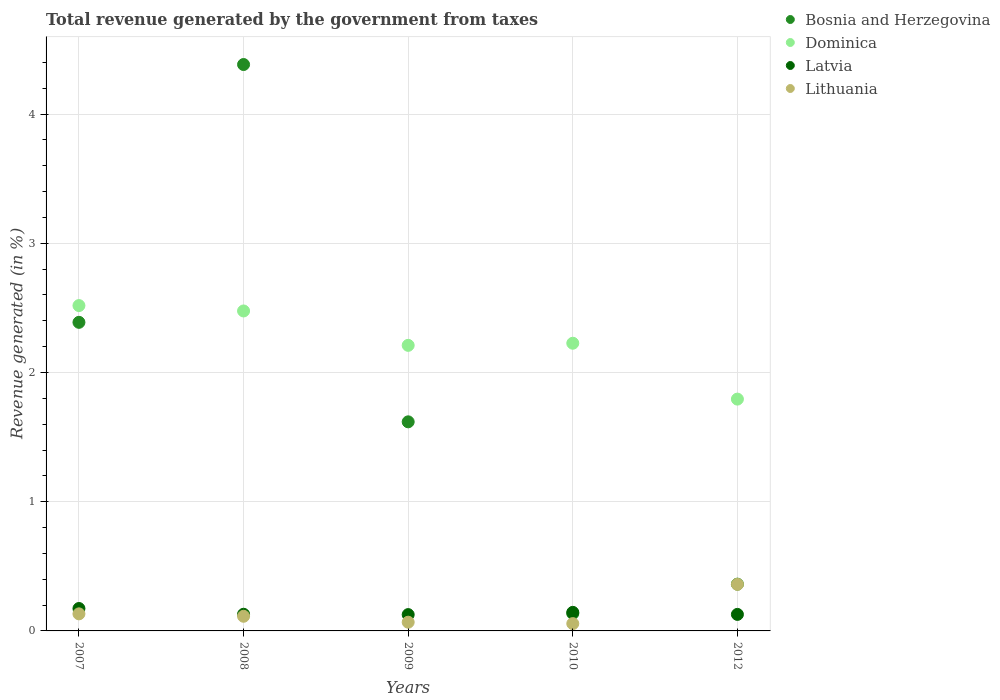How many different coloured dotlines are there?
Provide a short and direct response. 4. Is the number of dotlines equal to the number of legend labels?
Offer a terse response. Yes. What is the total revenue generated in Latvia in 2009?
Offer a very short reply. 0.13. Across all years, what is the maximum total revenue generated in Dominica?
Make the answer very short. 2.52. Across all years, what is the minimum total revenue generated in Dominica?
Provide a succinct answer. 1.79. What is the total total revenue generated in Latvia in the graph?
Make the answer very short. 0.7. What is the difference between the total revenue generated in Dominica in 2010 and that in 2012?
Offer a very short reply. 0.43. What is the difference between the total revenue generated in Lithuania in 2007 and the total revenue generated in Dominica in 2010?
Provide a succinct answer. -2.09. What is the average total revenue generated in Latvia per year?
Provide a short and direct response. 0.14. In the year 2010, what is the difference between the total revenue generated in Dominica and total revenue generated in Lithuania?
Ensure brevity in your answer.  2.17. What is the ratio of the total revenue generated in Latvia in 2009 to that in 2010?
Offer a terse response. 0.88. Is the total revenue generated in Bosnia and Herzegovina in 2009 less than that in 2012?
Your answer should be compact. No. Is the difference between the total revenue generated in Dominica in 2007 and 2012 greater than the difference between the total revenue generated in Lithuania in 2007 and 2012?
Give a very brief answer. Yes. What is the difference between the highest and the second highest total revenue generated in Latvia?
Ensure brevity in your answer.  0.03. What is the difference between the highest and the lowest total revenue generated in Dominica?
Your response must be concise. 0.72. Is the sum of the total revenue generated in Dominica in 2010 and 2012 greater than the maximum total revenue generated in Latvia across all years?
Ensure brevity in your answer.  Yes. Is it the case that in every year, the sum of the total revenue generated in Latvia and total revenue generated in Bosnia and Herzegovina  is greater than the sum of total revenue generated in Lithuania and total revenue generated in Dominica?
Offer a terse response. No. Is it the case that in every year, the sum of the total revenue generated in Latvia and total revenue generated in Dominica  is greater than the total revenue generated in Bosnia and Herzegovina?
Make the answer very short. No. Does the total revenue generated in Latvia monotonically increase over the years?
Your answer should be compact. No. How many dotlines are there?
Keep it short and to the point. 4. What is the difference between two consecutive major ticks on the Y-axis?
Keep it short and to the point. 1. Does the graph contain any zero values?
Offer a very short reply. No. Does the graph contain grids?
Ensure brevity in your answer.  Yes. Where does the legend appear in the graph?
Offer a very short reply. Top right. How are the legend labels stacked?
Provide a short and direct response. Vertical. What is the title of the graph?
Your response must be concise. Total revenue generated by the government from taxes. What is the label or title of the Y-axis?
Your response must be concise. Revenue generated (in %). What is the Revenue generated (in %) in Bosnia and Herzegovina in 2007?
Your answer should be compact. 2.39. What is the Revenue generated (in %) of Dominica in 2007?
Provide a short and direct response. 2.52. What is the Revenue generated (in %) in Latvia in 2007?
Provide a succinct answer. 0.17. What is the Revenue generated (in %) of Lithuania in 2007?
Offer a terse response. 0.13. What is the Revenue generated (in %) in Bosnia and Herzegovina in 2008?
Make the answer very short. 4.38. What is the Revenue generated (in %) in Dominica in 2008?
Offer a terse response. 2.48. What is the Revenue generated (in %) of Latvia in 2008?
Your answer should be compact. 0.13. What is the Revenue generated (in %) of Lithuania in 2008?
Give a very brief answer. 0.11. What is the Revenue generated (in %) in Bosnia and Herzegovina in 2009?
Offer a very short reply. 1.62. What is the Revenue generated (in %) in Dominica in 2009?
Your answer should be very brief. 2.21. What is the Revenue generated (in %) of Latvia in 2009?
Your answer should be compact. 0.13. What is the Revenue generated (in %) in Lithuania in 2009?
Your response must be concise. 0.07. What is the Revenue generated (in %) in Bosnia and Herzegovina in 2010?
Your answer should be very brief. 0.13. What is the Revenue generated (in %) in Dominica in 2010?
Make the answer very short. 2.23. What is the Revenue generated (in %) in Latvia in 2010?
Offer a terse response. 0.14. What is the Revenue generated (in %) of Lithuania in 2010?
Provide a succinct answer. 0.06. What is the Revenue generated (in %) of Bosnia and Herzegovina in 2012?
Keep it short and to the point. 0.36. What is the Revenue generated (in %) in Dominica in 2012?
Your answer should be compact. 1.79. What is the Revenue generated (in %) of Latvia in 2012?
Offer a terse response. 0.13. What is the Revenue generated (in %) of Lithuania in 2012?
Make the answer very short. 0.36. Across all years, what is the maximum Revenue generated (in %) of Bosnia and Herzegovina?
Keep it short and to the point. 4.38. Across all years, what is the maximum Revenue generated (in %) of Dominica?
Provide a short and direct response. 2.52. Across all years, what is the maximum Revenue generated (in %) in Latvia?
Provide a short and direct response. 0.17. Across all years, what is the maximum Revenue generated (in %) of Lithuania?
Keep it short and to the point. 0.36. Across all years, what is the minimum Revenue generated (in %) of Bosnia and Herzegovina?
Your response must be concise. 0.13. Across all years, what is the minimum Revenue generated (in %) of Dominica?
Offer a very short reply. 1.79. Across all years, what is the minimum Revenue generated (in %) of Latvia?
Ensure brevity in your answer.  0.13. Across all years, what is the minimum Revenue generated (in %) of Lithuania?
Offer a very short reply. 0.06. What is the total Revenue generated (in %) of Bosnia and Herzegovina in the graph?
Offer a very short reply. 8.89. What is the total Revenue generated (in %) of Dominica in the graph?
Offer a terse response. 11.22. What is the total Revenue generated (in %) in Latvia in the graph?
Provide a succinct answer. 0.7. What is the total Revenue generated (in %) in Lithuania in the graph?
Give a very brief answer. 0.73. What is the difference between the Revenue generated (in %) of Bosnia and Herzegovina in 2007 and that in 2008?
Keep it short and to the point. -2. What is the difference between the Revenue generated (in %) of Dominica in 2007 and that in 2008?
Make the answer very short. 0.04. What is the difference between the Revenue generated (in %) in Latvia in 2007 and that in 2008?
Keep it short and to the point. 0.04. What is the difference between the Revenue generated (in %) of Lithuania in 2007 and that in 2008?
Your answer should be very brief. 0.02. What is the difference between the Revenue generated (in %) in Bosnia and Herzegovina in 2007 and that in 2009?
Provide a succinct answer. 0.77. What is the difference between the Revenue generated (in %) of Dominica in 2007 and that in 2009?
Your answer should be very brief. 0.31. What is the difference between the Revenue generated (in %) of Latvia in 2007 and that in 2009?
Provide a short and direct response. 0.05. What is the difference between the Revenue generated (in %) of Lithuania in 2007 and that in 2009?
Keep it short and to the point. 0.06. What is the difference between the Revenue generated (in %) in Bosnia and Herzegovina in 2007 and that in 2010?
Give a very brief answer. 2.25. What is the difference between the Revenue generated (in %) of Dominica in 2007 and that in 2010?
Provide a succinct answer. 0.29. What is the difference between the Revenue generated (in %) of Latvia in 2007 and that in 2010?
Give a very brief answer. 0.03. What is the difference between the Revenue generated (in %) in Lithuania in 2007 and that in 2010?
Provide a short and direct response. 0.08. What is the difference between the Revenue generated (in %) in Bosnia and Herzegovina in 2007 and that in 2012?
Your answer should be very brief. 2.03. What is the difference between the Revenue generated (in %) of Dominica in 2007 and that in 2012?
Your answer should be very brief. 0.72. What is the difference between the Revenue generated (in %) in Latvia in 2007 and that in 2012?
Provide a succinct answer. 0.05. What is the difference between the Revenue generated (in %) of Lithuania in 2007 and that in 2012?
Provide a succinct answer. -0.23. What is the difference between the Revenue generated (in %) in Bosnia and Herzegovina in 2008 and that in 2009?
Ensure brevity in your answer.  2.76. What is the difference between the Revenue generated (in %) in Dominica in 2008 and that in 2009?
Your answer should be compact. 0.27. What is the difference between the Revenue generated (in %) of Latvia in 2008 and that in 2009?
Provide a succinct answer. 0. What is the difference between the Revenue generated (in %) in Lithuania in 2008 and that in 2009?
Keep it short and to the point. 0.05. What is the difference between the Revenue generated (in %) of Bosnia and Herzegovina in 2008 and that in 2010?
Your answer should be compact. 4.25. What is the difference between the Revenue generated (in %) in Dominica in 2008 and that in 2010?
Offer a very short reply. 0.25. What is the difference between the Revenue generated (in %) of Latvia in 2008 and that in 2010?
Keep it short and to the point. -0.01. What is the difference between the Revenue generated (in %) of Lithuania in 2008 and that in 2010?
Your answer should be very brief. 0.06. What is the difference between the Revenue generated (in %) of Bosnia and Herzegovina in 2008 and that in 2012?
Provide a short and direct response. 4.02. What is the difference between the Revenue generated (in %) of Dominica in 2008 and that in 2012?
Your answer should be compact. 0.68. What is the difference between the Revenue generated (in %) in Latvia in 2008 and that in 2012?
Offer a terse response. 0. What is the difference between the Revenue generated (in %) in Lithuania in 2008 and that in 2012?
Offer a terse response. -0.25. What is the difference between the Revenue generated (in %) in Bosnia and Herzegovina in 2009 and that in 2010?
Your response must be concise. 1.48. What is the difference between the Revenue generated (in %) of Dominica in 2009 and that in 2010?
Provide a succinct answer. -0.02. What is the difference between the Revenue generated (in %) in Latvia in 2009 and that in 2010?
Your answer should be very brief. -0.02. What is the difference between the Revenue generated (in %) of Lithuania in 2009 and that in 2010?
Your answer should be very brief. 0.01. What is the difference between the Revenue generated (in %) of Bosnia and Herzegovina in 2009 and that in 2012?
Offer a terse response. 1.26. What is the difference between the Revenue generated (in %) of Dominica in 2009 and that in 2012?
Ensure brevity in your answer.  0.42. What is the difference between the Revenue generated (in %) in Latvia in 2009 and that in 2012?
Keep it short and to the point. -0. What is the difference between the Revenue generated (in %) in Lithuania in 2009 and that in 2012?
Your answer should be compact. -0.29. What is the difference between the Revenue generated (in %) in Bosnia and Herzegovina in 2010 and that in 2012?
Your response must be concise. -0.23. What is the difference between the Revenue generated (in %) in Dominica in 2010 and that in 2012?
Your response must be concise. 0.43. What is the difference between the Revenue generated (in %) of Latvia in 2010 and that in 2012?
Give a very brief answer. 0.02. What is the difference between the Revenue generated (in %) of Lithuania in 2010 and that in 2012?
Ensure brevity in your answer.  -0.3. What is the difference between the Revenue generated (in %) of Bosnia and Herzegovina in 2007 and the Revenue generated (in %) of Dominica in 2008?
Your answer should be very brief. -0.09. What is the difference between the Revenue generated (in %) of Bosnia and Herzegovina in 2007 and the Revenue generated (in %) of Latvia in 2008?
Offer a very short reply. 2.26. What is the difference between the Revenue generated (in %) of Bosnia and Herzegovina in 2007 and the Revenue generated (in %) of Lithuania in 2008?
Provide a succinct answer. 2.27. What is the difference between the Revenue generated (in %) in Dominica in 2007 and the Revenue generated (in %) in Latvia in 2008?
Ensure brevity in your answer.  2.39. What is the difference between the Revenue generated (in %) in Dominica in 2007 and the Revenue generated (in %) in Lithuania in 2008?
Your answer should be compact. 2.4. What is the difference between the Revenue generated (in %) of Latvia in 2007 and the Revenue generated (in %) of Lithuania in 2008?
Your answer should be compact. 0.06. What is the difference between the Revenue generated (in %) of Bosnia and Herzegovina in 2007 and the Revenue generated (in %) of Dominica in 2009?
Provide a short and direct response. 0.18. What is the difference between the Revenue generated (in %) of Bosnia and Herzegovina in 2007 and the Revenue generated (in %) of Latvia in 2009?
Your answer should be very brief. 2.26. What is the difference between the Revenue generated (in %) of Bosnia and Herzegovina in 2007 and the Revenue generated (in %) of Lithuania in 2009?
Offer a very short reply. 2.32. What is the difference between the Revenue generated (in %) of Dominica in 2007 and the Revenue generated (in %) of Latvia in 2009?
Offer a terse response. 2.39. What is the difference between the Revenue generated (in %) in Dominica in 2007 and the Revenue generated (in %) in Lithuania in 2009?
Provide a succinct answer. 2.45. What is the difference between the Revenue generated (in %) in Latvia in 2007 and the Revenue generated (in %) in Lithuania in 2009?
Your response must be concise. 0.11. What is the difference between the Revenue generated (in %) of Bosnia and Herzegovina in 2007 and the Revenue generated (in %) of Dominica in 2010?
Offer a terse response. 0.16. What is the difference between the Revenue generated (in %) of Bosnia and Herzegovina in 2007 and the Revenue generated (in %) of Latvia in 2010?
Keep it short and to the point. 2.24. What is the difference between the Revenue generated (in %) of Bosnia and Herzegovina in 2007 and the Revenue generated (in %) of Lithuania in 2010?
Offer a terse response. 2.33. What is the difference between the Revenue generated (in %) of Dominica in 2007 and the Revenue generated (in %) of Latvia in 2010?
Provide a succinct answer. 2.37. What is the difference between the Revenue generated (in %) in Dominica in 2007 and the Revenue generated (in %) in Lithuania in 2010?
Your answer should be compact. 2.46. What is the difference between the Revenue generated (in %) of Latvia in 2007 and the Revenue generated (in %) of Lithuania in 2010?
Give a very brief answer. 0.12. What is the difference between the Revenue generated (in %) in Bosnia and Herzegovina in 2007 and the Revenue generated (in %) in Dominica in 2012?
Give a very brief answer. 0.59. What is the difference between the Revenue generated (in %) of Bosnia and Herzegovina in 2007 and the Revenue generated (in %) of Latvia in 2012?
Your response must be concise. 2.26. What is the difference between the Revenue generated (in %) of Bosnia and Herzegovina in 2007 and the Revenue generated (in %) of Lithuania in 2012?
Offer a terse response. 2.03. What is the difference between the Revenue generated (in %) of Dominica in 2007 and the Revenue generated (in %) of Latvia in 2012?
Your answer should be compact. 2.39. What is the difference between the Revenue generated (in %) in Dominica in 2007 and the Revenue generated (in %) in Lithuania in 2012?
Provide a succinct answer. 2.16. What is the difference between the Revenue generated (in %) of Latvia in 2007 and the Revenue generated (in %) of Lithuania in 2012?
Your answer should be compact. -0.19. What is the difference between the Revenue generated (in %) in Bosnia and Herzegovina in 2008 and the Revenue generated (in %) in Dominica in 2009?
Provide a short and direct response. 2.17. What is the difference between the Revenue generated (in %) in Bosnia and Herzegovina in 2008 and the Revenue generated (in %) in Latvia in 2009?
Provide a succinct answer. 4.26. What is the difference between the Revenue generated (in %) in Bosnia and Herzegovina in 2008 and the Revenue generated (in %) in Lithuania in 2009?
Your answer should be compact. 4.32. What is the difference between the Revenue generated (in %) in Dominica in 2008 and the Revenue generated (in %) in Latvia in 2009?
Your answer should be very brief. 2.35. What is the difference between the Revenue generated (in %) of Dominica in 2008 and the Revenue generated (in %) of Lithuania in 2009?
Your answer should be compact. 2.41. What is the difference between the Revenue generated (in %) of Latvia in 2008 and the Revenue generated (in %) of Lithuania in 2009?
Provide a short and direct response. 0.06. What is the difference between the Revenue generated (in %) in Bosnia and Herzegovina in 2008 and the Revenue generated (in %) in Dominica in 2010?
Offer a very short reply. 2.16. What is the difference between the Revenue generated (in %) in Bosnia and Herzegovina in 2008 and the Revenue generated (in %) in Latvia in 2010?
Make the answer very short. 4.24. What is the difference between the Revenue generated (in %) of Bosnia and Herzegovina in 2008 and the Revenue generated (in %) of Lithuania in 2010?
Keep it short and to the point. 4.33. What is the difference between the Revenue generated (in %) in Dominica in 2008 and the Revenue generated (in %) in Latvia in 2010?
Offer a very short reply. 2.33. What is the difference between the Revenue generated (in %) of Dominica in 2008 and the Revenue generated (in %) of Lithuania in 2010?
Offer a terse response. 2.42. What is the difference between the Revenue generated (in %) in Latvia in 2008 and the Revenue generated (in %) in Lithuania in 2010?
Give a very brief answer. 0.07. What is the difference between the Revenue generated (in %) of Bosnia and Herzegovina in 2008 and the Revenue generated (in %) of Dominica in 2012?
Give a very brief answer. 2.59. What is the difference between the Revenue generated (in %) in Bosnia and Herzegovina in 2008 and the Revenue generated (in %) in Latvia in 2012?
Make the answer very short. 4.26. What is the difference between the Revenue generated (in %) of Bosnia and Herzegovina in 2008 and the Revenue generated (in %) of Lithuania in 2012?
Ensure brevity in your answer.  4.02. What is the difference between the Revenue generated (in %) of Dominica in 2008 and the Revenue generated (in %) of Latvia in 2012?
Make the answer very short. 2.35. What is the difference between the Revenue generated (in %) of Dominica in 2008 and the Revenue generated (in %) of Lithuania in 2012?
Give a very brief answer. 2.12. What is the difference between the Revenue generated (in %) of Latvia in 2008 and the Revenue generated (in %) of Lithuania in 2012?
Make the answer very short. -0.23. What is the difference between the Revenue generated (in %) of Bosnia and Herzegovina in 2009 and the Revenue generated (in %) of Dominica in 2010?
Your response must be concise. -0.61. What is the difference between the Revenue generated (in %) of Bosnia and Herzegovina in 2009 and the Revenue generated (in %) of Latvia in 2010?
Provide a short and direct response. 1.47. What is the difference between the Revenue generated (in %) in Bosnia and Herzegovina in 2009 and the Revenue generated (in %) in Lithuania in 2010?
Provide a succinct answer. 1.56. What is the difference between the Revenue generated (in %) in Dominica in 2009 and the Revenue generated (in %) in Latvia in 2010?
Your answer should be very brief. 2.07. What is the difference between the Revenue generated (in %) in Dominica in 2009 and the Revenue generated (in %) in Lithuania in 2010?
Offer a very short reply. 2.15. What is the difference between the Revenue generated (in %) of Latvia in 2009 and the Revenue generated (in %) of Lithuania in 2010?
Give a very brief answer. 0.07. What is the difference between the Revenue generated (in %) of Bosnia and Herzegovina in 2009 and the Revenue generated (in %) of Dominica in 2012?
Your response must be concise. -0.18. What is the difference between the Revenue generated (in %) of Bosnia and Herzegovina in 2009 and the Revenue generated (in %) of Latvia in 2012?
Your response must be concise. 1.49. What is the difference between the Revenue generated (in %) in Bosnia and Herzegovina in 2009 and the Revenue generated (in %) in Lithuania in 2012?
Ensure brevity in your answer.  1.26. What is the difference between the Revenue generated (in %) in Dominica in 2009 and the Revenue generated (in %) in Latvia in 2012?
Your answer should be compact. 2.08. What is the difference between the Revenue generated (in %) of Dominica in 2009 and the Revenue generated (in %) of Lithuania in 2012?
Your answer should be very brief. 1.85. What is the difference between the Revenue generated (in %) of Latvia in 2009 and the Revenue generated (in %) of Lithuania in 2012?
Offer a very short reply. -0.23. What is the difference between the Revenue generated (in %) of Bosnia and Herzegovina in 2010 and the Revenue generated (in %) of Dominica in 2012?
Give a very brief answer. -1.66. What is the difference between the Revenue generated (in %) in Bosnia and Herzegovina in 2010 and the Revenue generated (in %) in Latvia in 2012?
Your answer should be compact. 0.01. What is the difference between the Revenue generated (in %) of Bosnia and Herzegovina in 2010 and the Revenue generated (in %) of Lithuania in 2012?
Provide a short and direct response. -0.23. What is the difference between the Revenue generated (in %) in Dominica in 2010 and the Revenue generated (in %) in Latvia in 2012?
Keep it short and to the point. 2.1. What is the difference between the Revenue generated (in %) of Dominica in 2010 and the Revenue generated (in %) of Lithuania in 2012?
Your response must be concise. 1.87. What is the difference between the Revenue generated (in %) in Latvia in 2010 and the Revenue generated (in %) in Lithuania in 2012?
Give a very brief answer. -0.22. What is the average Revenue generated (in %) in Bosnia and Herzegovina per year?
Your answer should be compact. 1.78. What is the average Revenue generated (in %) of Dominica per year?
Your answer should be very brief. 2.24. What is the average Revenue generated (in %) in Latvia per year?
Ensure brevity in your answer.  0.14. What is the average Revenue generated (in %) in Lithuania per year?
Your answer should be compact. 0.15. In the year 2007, what is the difference between the Revenue generated (in %) in Bosnia and Herzegovina and Revenue generated (in %) in Dominica?
Offer a terse response. -0.13. In the year 2007, what is the difference between the Revenue generated (in %) of Bosnia and Herzegovina and Revenue generated (in %) of Latvia?
Provide a short and direct response. 2.21. In the year 2007, what is the difference between the Revenue generated (in %) in Bosnia and Herzegovina and Revenue generated (in %) in Lithuania?
Offer a terse response. 2.26. In the year 2007, what is the difference between the Revenue generated (in %) of Dominica and Revenue generated (in %) of Latvia?
Make the answer very short. 2.34. In the year 2007, what is the difference between the Revenue generated (in %) of Dominica and Revenue generated (in %) of Lithuania?
Your response must be concise. 2.39. In the year 2007, what is the difference between the Revenue generated (in %) in Latvia and Revenue generated (in %) in Lithuania?
Keep it short and to the point. 0.04. In the year 2008, what is the difference between the Revenue generated (in %) in Bosnia and Herzegovina and Revenue generated (in %) in Dominica?
Ensure brevity in your answer.  1.91. In the year 2008, what is the difference between the Revenue generated (in %) in Bosnia and Herzegovina and Revenue generated (in %) in Latvia?
Provide a succinct answer. 4.25. In the year 2008, what is the difference between the Revenue generated (in %) of Bosnia and Herzegovina and Revenue generated (in %) of Lithuania?
Offer a very short reply. 4.27. In the year 2008, what is the difference between the Revenue generated (in %) in Dominica and Revenue generated (in %) in Latvia?
Ensure brevity in your answer.  2.35. In the year 2008, what is the difference between the Revenue generated (in %) of Dominica and Revenue generated (in %) of Lithuania?
Keep it short and to the point. 2.36. In the year 2008, what is the difference between the Revenue generated (in %) of Latvia and Revenue generated (in %) of Lithuania?
Your answer should be compact. 0.02. In the year 2009, what is the difference between the Revenue generated (in %) of Bosnia and Herzegovina and Revenue generated (in %) of Dominica?
Your answer should be very brief. -0.59. In the year 2009, what is the difference between the Revenue generated (in %) of Bosnia and Herzegovina and Revenue generated (in %) of Latvia?
Your answer should be very brief. 1.49. In the year 2009, what is the difference between the Revenue generated (in %) of Bosnia and Herzegovina and Revenue generated (in %) of Lithuania?
Your answer should be very brief. 1.55. In the year 2009, what is the difference between the Revenue generated (in %) in Dominica and Revenue generated (in %) in Latvia?
Keep it short and to the point. 2.08. In the year 2009, what is the difference between the Revenue generated (in %) of Dominica and Revenue generated (in %) of Lithuania?
Ensure brevity in your answer.  2.14. In the year 2009, what is the difference between the Revenue generated (in %) in Latvia and Revenue generated (in %) in Lithuania?
Provide a succinct answer. 0.06. In the year 2010, what is the difference between the Revenue generated (in %) in Bosnia and Herzegovina and Revenue generated (in %) in Dominica?
Ensure brevity in your answer.  -2.09. In the year 2010, what is the difference between the Revenue generated (in %) in Bosnia and Herzegovina and Revenue generated (in %) in Latvia?
Your answer should be compact. -0.01. In the year 2010, what is the difference between the Revenue generated (in %) of Bosnia and Herzegovina and Revenue generated (in %) of Lithuania?
Your answer should be compact. 0.08. In the year 2010, what is the difference between the Revenue generated (in %) of Dominica and Revenue generated (in %) of Latvia?
Give a very brief answer. 2.08. In the year 2010, what is the difference between the Revenue generated (in %) in Dominica and Revenue generated (in %) in Lithuania?
Give a very brief answer. 2.17. In the year 2010, what is the difference between the Revenue generated (in %) of Latvia and Revenue generated (in %) of Lithuania?
Keep it short and to the point. 0.09. In the year 2012, what is the difference between the Revenue generated (in %) of Bosnia and Herzegovina and Revenue generated (in %) of Dominica?
Provide a short and direct response. -1.43. In the year 2012, what is the difference between the Revenue generated (in %) of Bosnia and Herzegovina and Revenue generated (in %) of Latvia?
Your answer should be very brief. 0.23. In the year 2012, what is the difference between the Revenue generated (in %) of Bosnia and Herzegovina and Revenue generated (in %) of Lithuania?
Offer a terse response. 0. In the year 2012, what is the difference between the Revenue generated (in %) in Dominica and Revenue generated (in %) in Latvia?
Your answer should be very brief. 1.67. In the year 2012, what is the difference between the Revenue generated (in %) of Dominica and Revenue generated (in %) of Lithuania?
Your answer should be very brief. 1.43. In the year 2012, what is the difference between the Revenue generated (in %) of Latvia and Revenue generated (in %) of Lithuania?
Give a very brief answer. -0.23. What is the ratio of the Revenue generated (in %) of Bosnia and Herzegovina in 2007 to that in 2008?
Your answer should be very brief. 0.54. What is the ratio of the Revenue generated (in %) of Dominica in 2007 to that in 2008?
Provide a succinct answer. 1.02. What is the ratio of the Revenue generated (in %) of Latvia in 2007 to that in 2008?
Offer a very short reply. 1.35. What is the ratio of the Revenue generated (in %) in Lithuania in 2007 to that in 2008?
Keep it short and to the point. 1.16. What is the ratio of the Revenue generated (in %) of Bosnia and Herzegovina in 2007 to that in 2009?
Offer a very short reply. 1.48. What is the ratio of the Revenue generated (in %) in Dominica in 2007 to that in 2009?
Your answer should be very brief. 1.14. What is the ratio of the Revenue generated (in %) of Latvia in 2007 to that in 2009?
Ensure brevity in your answer.  1.37. What is the ratio of the Revenue generated (in %) of Lithuania in 2007 to that in 2009?
Ensure brevity in your answer.  1.96. What is the ratio of the Revenue generated (in %) of Bosnia and Herzegovina in 2007 to that in 2010?
Offer a terse response. 17.73. What is the ratio of the Revenue generated (in %) in Dominica in 2007 to that in 2010?
Keep it short and to the point. 1.13. What is the ratio of the Revenue generated (in %) in Latvia in 2007 to that in 2010?
Provide a short and direct response. 1.21. What is the ratio of the Revenue generated (in %) of Lithuania in 2007 to that in 2010?
Ensure brevity in your answer.  2.33. What is the ratio of the Revenue generated (in %) in Bosnia and Herzegovina in 2007 to that in 2012?
Give a very brief answer. 6.6. What is the ratio of the Revenue generated (in %) in Dominica in 2007 to that in 2012?
Your answer should be compact. 1.4. What is the ratio of the Revenue generated (in %) in Latvia in 2007 to that in 2012?
Provide a short and direct response. 1.36. What is the ratio of the Revenue generated (in %) of Lithuania in 2007 to that in 2012?
Make the answer very short. 0.37. What is the ratio of the Revenue generated (in %) in Bosnia and Herzegovina in 2008 to that in 2009?
Offer a very short reply. 2.71. What is the ratio of the Revenue generated (in %) of Dominica in 2008 to that in 2009?
Ensure brevity in your answer.  1.12. What is the ratio of the Revenue generated (in %) of Latvia in 2008 to that in 2009?
Offer a terse response. 1.02. What is the ratio of the Revenue generated (in %) of Lithuania in 2008 to that in 2009?
Provide a short and direct response. 1.68. What is the ratio of the Revenue generated (in %) of Bosnia and Herzegovina in 2008 to that in 2010?
Give a very brief answer. 32.55. What is the ratio of the Revenue generated (in %) of Dominica in 2008 to that in 2010?
Keep it short and to the point. 1.11. What is the ratio of the Revenue generated (in %) in Latvia in 2008 to that in 2010?
Provide a succinct answer. 0.9. What is the ratio of the Revenue generated (in %) of Lithuania in 2008 to that in 2010?
Keep it short and to the point. 2. What is the ratio of the Revenue generated (in %) in Bosnia and Herzegovina in 2008 to that in 2012?
Offer a terse response. 12.11. What is the ratio of the Revenue generated (in %) of Dominica in 2008 to that in 2012?
Give a very brief answer. 1.38. What is the ratio of the Revenue generated (in %) in Latvia in 2008 to that in 2012?
Your response must be concise. 1.01. What is the ratio of the Revenue generated (in %) of Lithuania in 2008 to that in 2012?
Ensure brevity in your answer.  0.31. What is the ratio of the Revenue generated (in %) of Bosnia and Herzegovina in 2009 to that in 2010?
Give a very brief answer. 12.02. What is the ratio of the Revenue generated (in %) of Dominica in 2009 to that in 2010?
Give a very brief answer. 0.99. What is the ratio of the Revenue generated (in %) in Latvia in 2009 to that in 2010?
Provide a succinct answer. 0.88. What is the ratio of the Revenue generated (in %) of Lithuania in 2009 to that in 2010?
Offer a terse response. 1.19. What is the ratio of the Revenue generated (in %) in Bosnia and Herzegovina in 2009 to that in 2012?
Make the answer very short. 4.47. What is the ratio of the Revenue generated (in %) of Dominica in 2009 to that in 2012?
Provide a short and direct response. 1.23. What is the ratio of the Revenue generated (in %) in Latvia in 2009 to that in 2012?
Your response must be concise. 0.99. What is the ratio of the Revenue generated (in %) in Lithuania in 2009 to that in 2012?
Your answer should be very brief. 0.19. What is the ratio of the Revenue generated (in %) of Bosnia and Herzegovina in 2010 to that in 2012?
Provide a succinct answer. 0.37. What is the ratio of the Revenue generated (in %) of Dominica in 2010 to that in 2012?
Your response must be concise. 1.24. What is the ratio of the Revenue generated (in %) of Latvia in 2010 to that in 2012?
Keep it short and to the point. 1.12. What is the ratio of the Revenue generated (in %) in Lithuania in 2010 to that in 2012?
Offer a very short reply. 0.16. What is the difference between the highest and the second highest Revenue generated (in %) of Bosnia and Herzegovina?
Offer a terse response. 2. What is the difference between the highest and the second highest Revenue generated (in %) of Dominica?
Your response must be concise. 0.04. What is the difference between the highest and the second highest Revenue generated (in %) of Latvia?
Keep it short and to the point. 0.03. What is the difference between the highest and the second highest Revenue generated (in %) in Lithuania?
Provide a succinct answer. 0.23. What is the difference between the highest and the lowest Revenue generated (in %) of Bosnia and Herzegovina?
Your answer should be very brief. 4.25. What is the difference between the highest and the lowest Revenue generated (in %) in Dominica?
Your response must be concise. 0.72. What is the difference between the highest and the lowest Revenue generated (in %) of Latvia?
Ensure brevity in your answer.  0.05. What is the difference between the highest and the lowest Revenue generated (in %) in Lithuania?
Your answer should be compact. 0.3. 